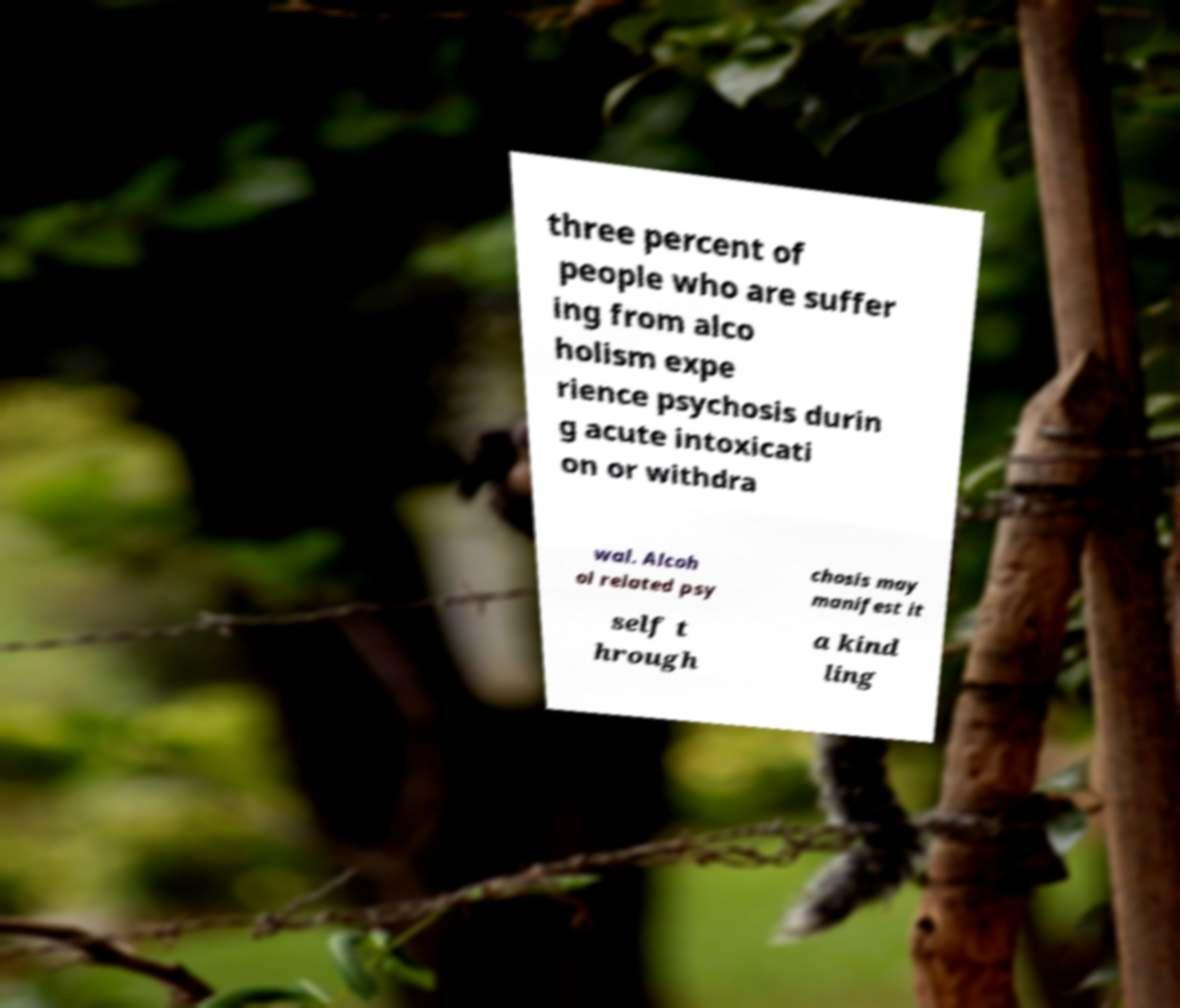Can you accurately transcribe the text from the provided image for me? three percent of people who are suffer ing from alco holism expe rience psychosis durin g acute intoxicati on or withdra wal. Alcoh ol related psy chosis may manifest it self t hrough a kind ling 